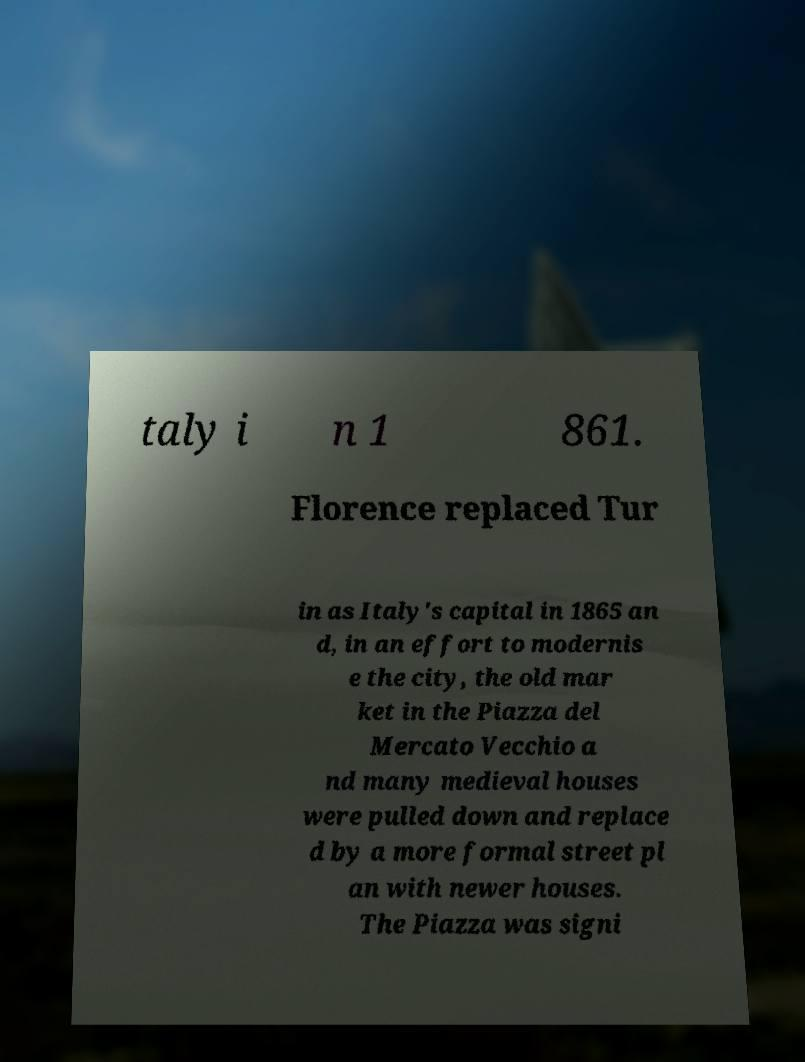Could you extract and type out the text from this image? taly i n 1 861. Florence replaced Tur in as Italy's capital in 1865 an d, in an effort to modernis e the city, the old mar ket in the Piazza del Mercato Vecchio a nd many medieval houses were pulled down and replace d by a more formal street pl an with newer houses. The Piazza was signi 